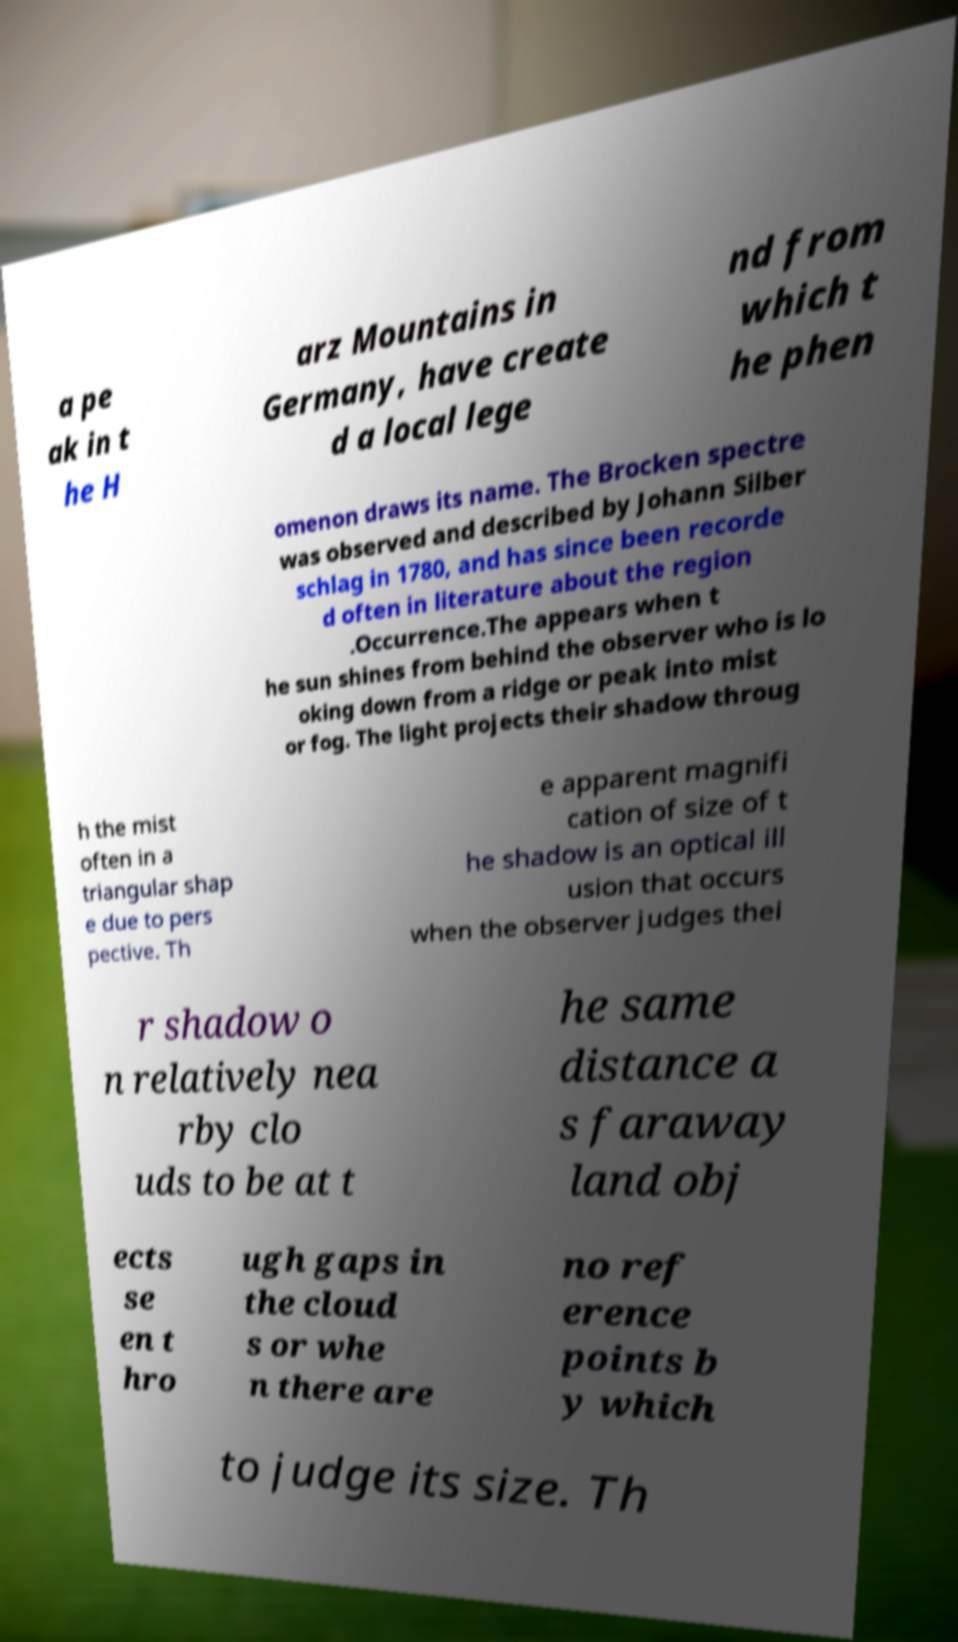I need the written content from this picture converted into text. Can you do that? a pe ak in t he H arz Mountains in Germany, have create d a local lege nd from which t he phen omenon draws its name. The Brocken spectre was observed and described by Johann Silber schlag in 1780, and has since been recorde d often in literature about the region .Occurrence.The appears when t he sun shines from behind the observer who is lo oking down from a ridge or peak into mist or fog. The light projects their shadow throug h the mist often in a triangular shap e due to pers pective. Th e apparent magnifi cation of size of t he shadow is an optical ill usion that occurs when the observer judges thei r shadow o n relatively nea rby clo uds to be at t he same distance a s faraway land obj ects se en t hro ugh gaps in the cloud s or whe n there are no ref erence points b y which to judge its size. Th 